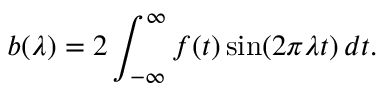<formula> <loc_0><loc_0><loc_500><loc_500>b ( \lambda ) = 2 \int _ { - \infty } ^ { \infty } f ( t ) \sin ( 2 \pi \lambda t ) \, d t .</formula> 